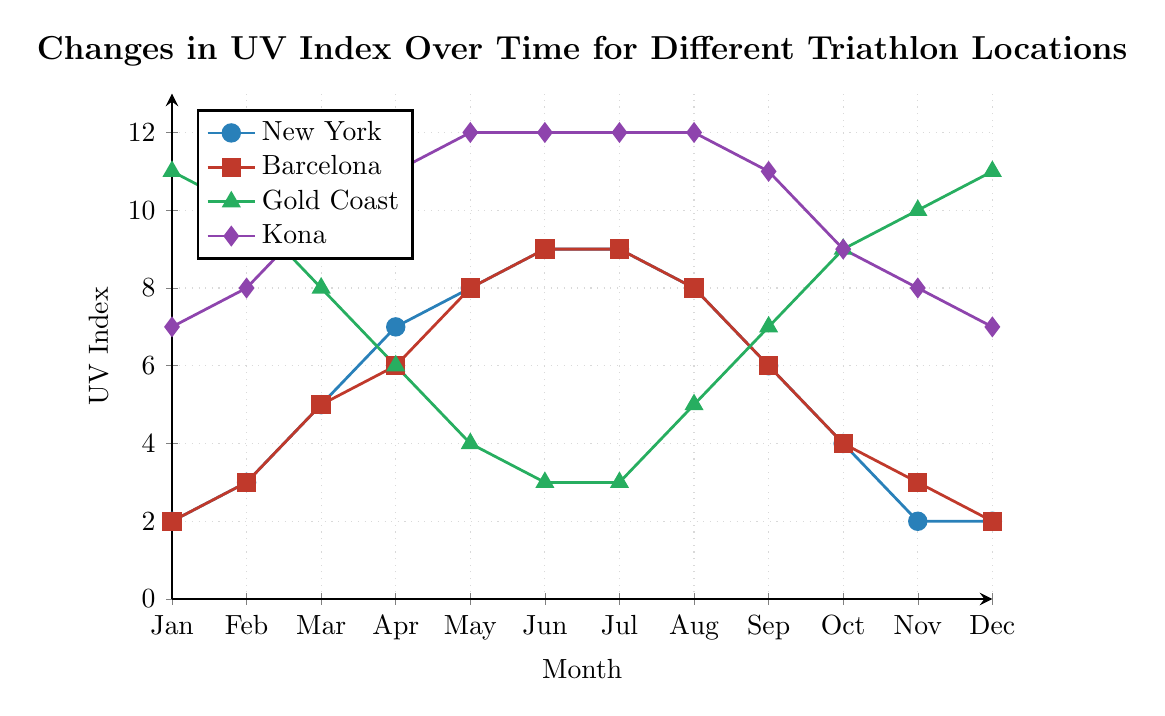What is the highest UV index recorded for Gold Coast throughout the year? By observing the line representing Gold Coast, the peak UV index can be identified directly from the plot. The highest point for Gold Coast is at 11, 10, and 9 months, where the UV index is 11, 10, and 10 respectively.
Answer: 11 During which month is the UV index difference between New York and Kona the greatest? To determine this, look at the vertical distance between New York and Kona lines across all months. The largest difference is in June and July, where New York has a UV index of 9 and Kona has a UV index of 12. The difference is 3.
Answer: June and July Which city experiences the lowest UV index in December, and what is that value? By observing the data points for December, we see that New York and Barcelona both have the lowest UV index of 2. Gold Coast has 11 and Kona has 7, which are higher.
Answer: New York and Barcelona, 2 How does the UV index in Barcelona change from January to December? Trace the line corresponding to Barcelona from January to December. The UV index starts at 2 in January, increases to 3 in February, gradually rises to 9 in both June and July, decreases back to 2 in December.
Answer: Starts at 2, peaks at 9, ends at 2 Which city has the most constant UV index throughout the year and what range does it fall in? By examining the smoothness and flatness of the lines, Kona has the most constant UV index as its values remain closely around 7 to 12 throughout the year.
Answer: Kona, 7 to 12 On average, which month has the highest UV index across all four cities? Summing the UV indices for all cities for each month, then average the sum for each month. For example, January: (2 + 2 + 11 + 7)/4 = 5.5, repeating for each month and comparing.
Answer: June and July How does the UV index of New York in January compare with that in May? Simply compare the UV index for New York in January (2) to that in May (8).
Answer: January 2, May 8 Which city has the maximum UV index in March, and what is that value? Looking at the month of March, the highest vertical point between New York, Barcelona, Gold Coast, and Kona, we see that Kona has a UV index of 11.
Answer: Kona, 11 What is the total accumulated UV index for Barcelona over the entire year? Summing the UV index values for each month for Barcelona: 2 + 3 + 5 + 6 + 8 + 9 + 9 + 8 + 6 + 4 + 3 + 2 = 65
Answer: 65 